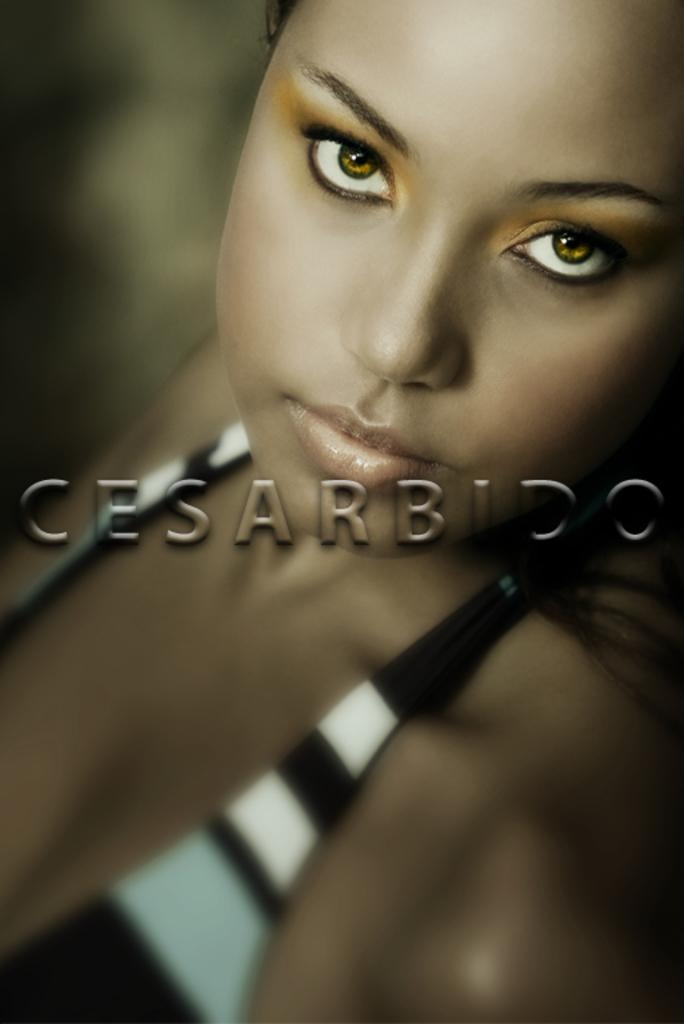What is the main subject of the image? The main subject of the image is a woman. Can you describe any additional features or elements in the image? Yes, there is text or writing on the image. How many dogs are visible in the image? There are no dogs present in the image. What type of pies can be seen in the image? There are no pies present in the image. 